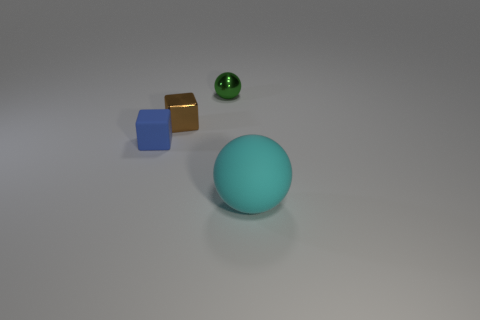How big is the cyan matte thing?
Your answer should be very brief. Large. How many cylinders are either large things or small things?
Keep it short and to the point. 0. What is the size of the other object that is made of the same material as the cyan thing?
Your answer should be very brief. Small. There is a blue thing; are there any tiny objects to the right of it?
Offer a very short reply. Yes. Does the tiny green object have the same shape as the rubber object on the left side of the big cyan object?
Your response must be concise. No. How many objects are objects that are behind the large ball or big purple cylinders?
Your response must be concise. 3. Are there any other things that are made of the same material as the blue thing?
Make the answer very short. Yes. How many spheres are both right of the tiny green metallic ball and to the left of the large sphere?
Your response must be concise. 0. What number of objects are either things that are left of the big cyan thing or rubber things that are on the right side of the brown thing?
Your answer should be compact. 4. What number of other things are there of the same shape as the small brown shiny object?
Your answer should be very brief. 1. 